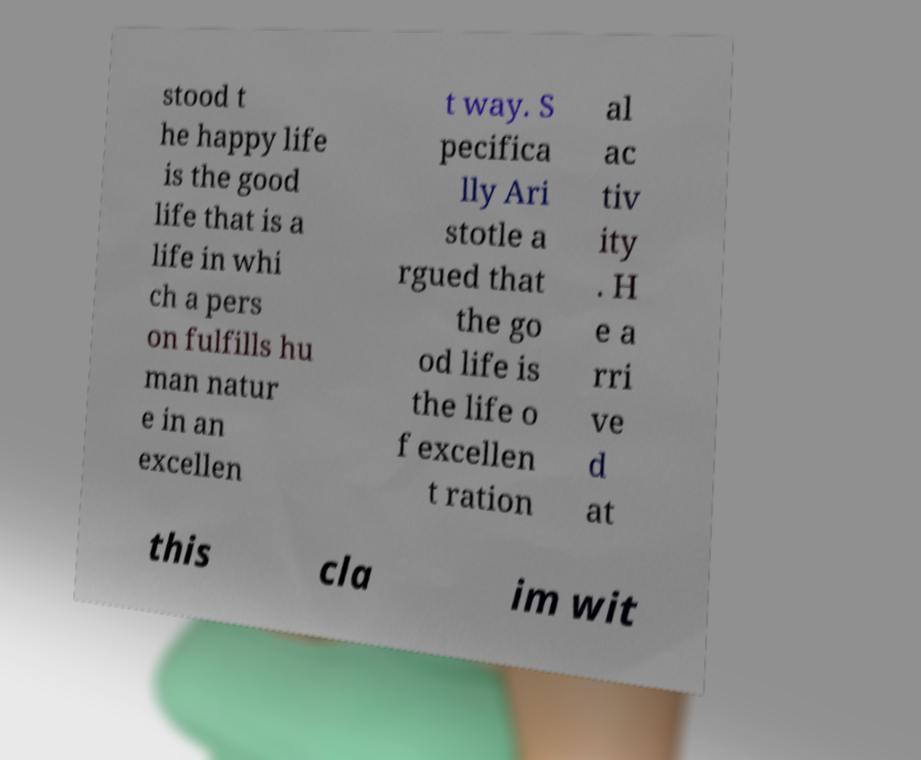Could you assist in decoding the text presented in this image and type it out clearly? stood t he happy life is the good life that is a life in whi ch a pers on fulfills hu man natur e in an excellen t way. S pecifica lly Ari stotle a rgued that the go od life is the life o f excellen t ration al ac tiv ity . H e a rri ve d at this cla im wit 